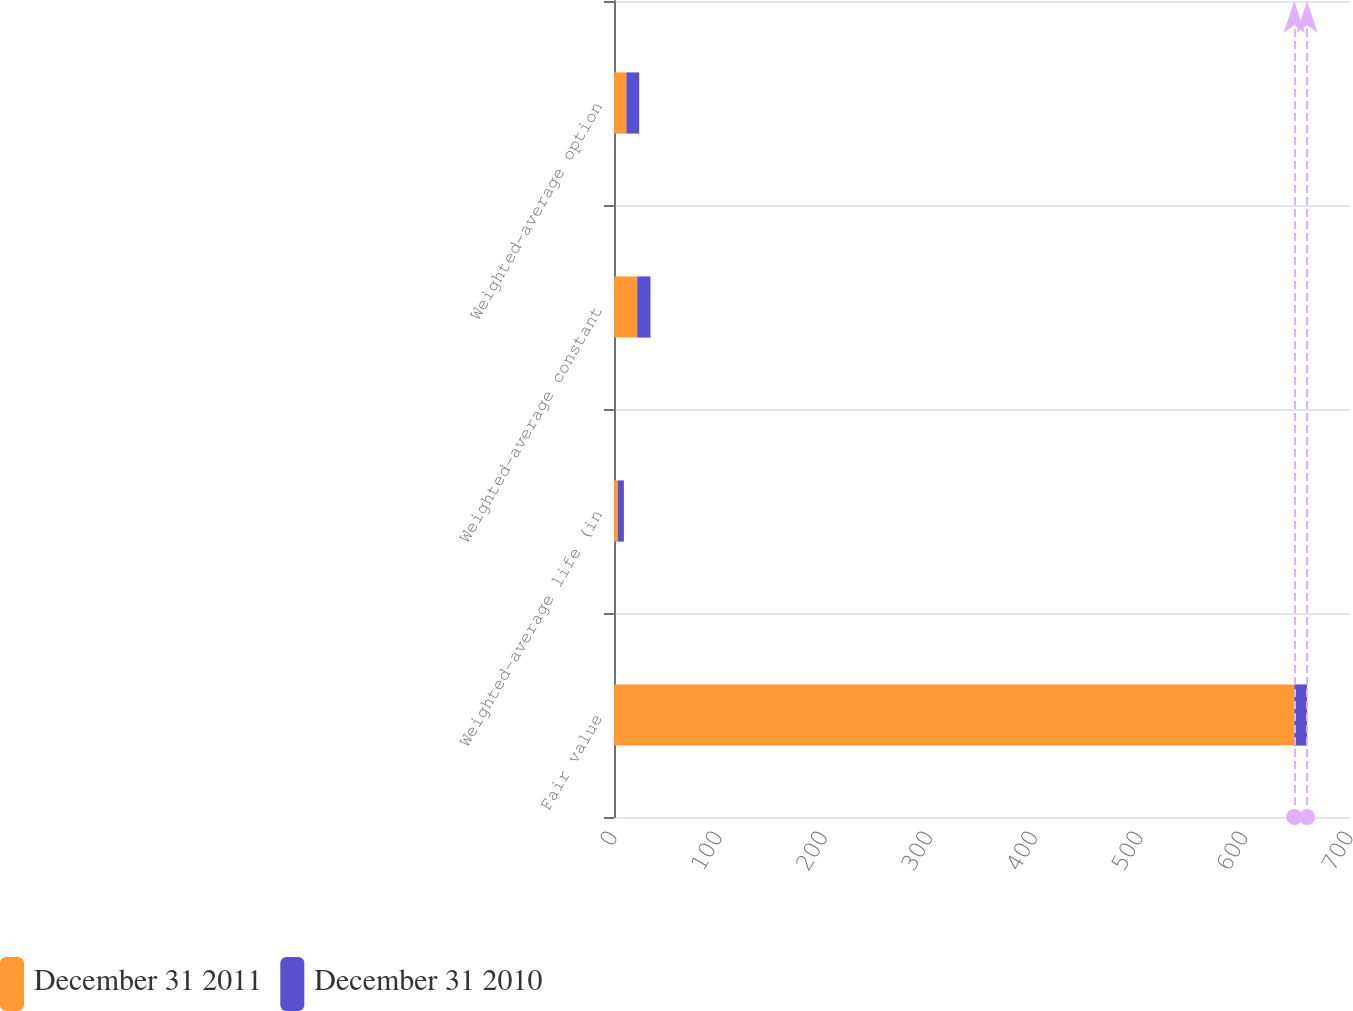Convert chart to OTSL. <chart><loc_0><loc_0><loc_500><loc_500><stacked_bar_chart><ecel><fcel>Fair value<fcel>Weighted-average life (in<fcel>Weighted-average constant<fcel>Weighted-average option<nl><fcel>December 31 2011<fcel>647<fcel>3.6<fcel>22.1<fcel>11.77<nl><fcel>December 31 2010<fcel>12.18<fcel>5.8<fcel>12.61<fcel>12.18<nl></chart> 